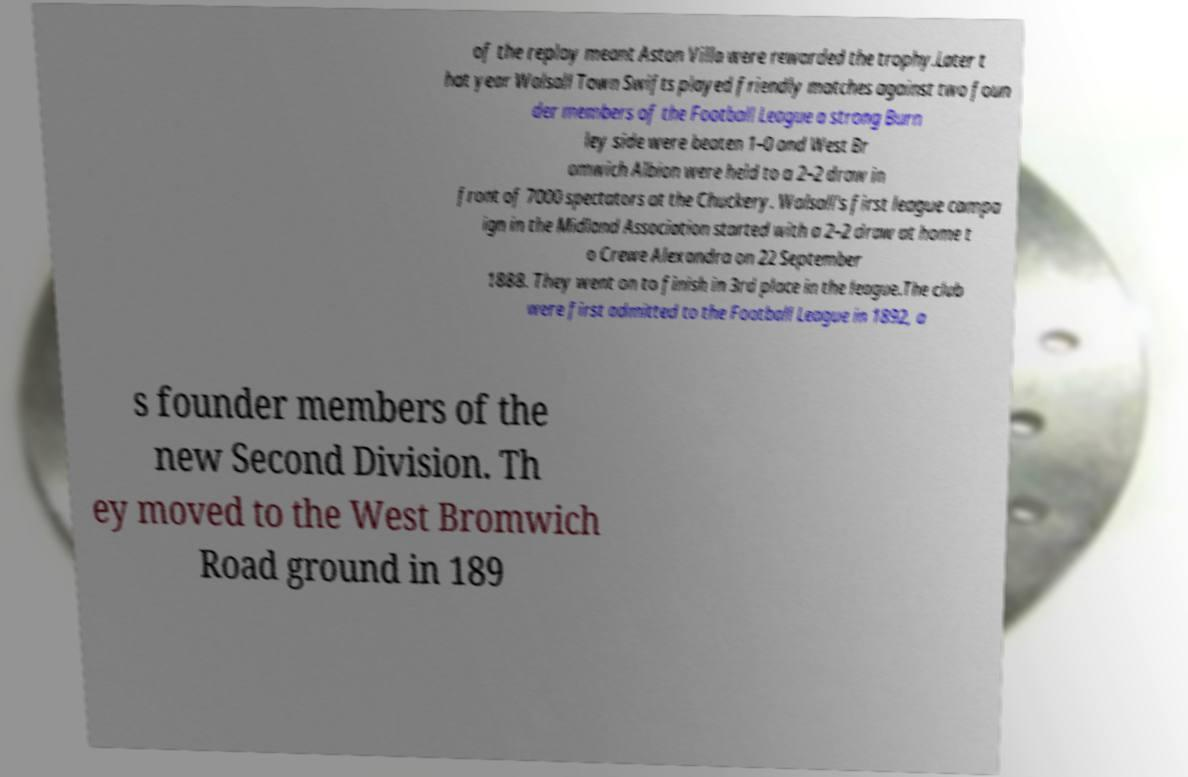Please read and relay the text visible in this image. What does it say? of the replay meant Aston Villa were rewarded the trophy.Later t hat year Walsall Town Swifts played friendly matches against two foun der members of the Football League a strong Burn ley side were beaten 1–0 and West Br omwich Albion were held to a 2–2 draw in front of 7000 spectators at the Chuckery. Walsall's first league campa ign in the Midland Association started with a 2–2 draw at home t o Crewe Alexandra on 22 September 1888. They went on to finish in 3rd place in the league.The club were first admitted to the Football League in 1892, a s founder members of the new Second Division. Th ey moved to the West Bromwich Road ground in 189 